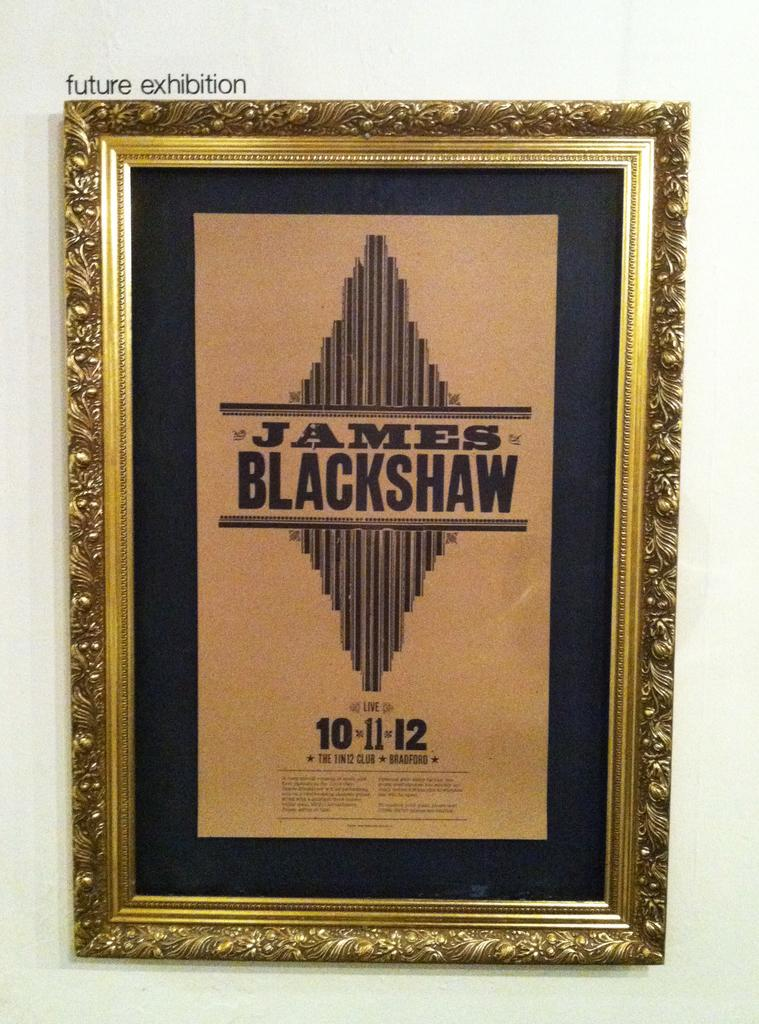<image>
Describe the image concisely. A framed poster for James Blackshaw hangs in a fancy gold frame. 